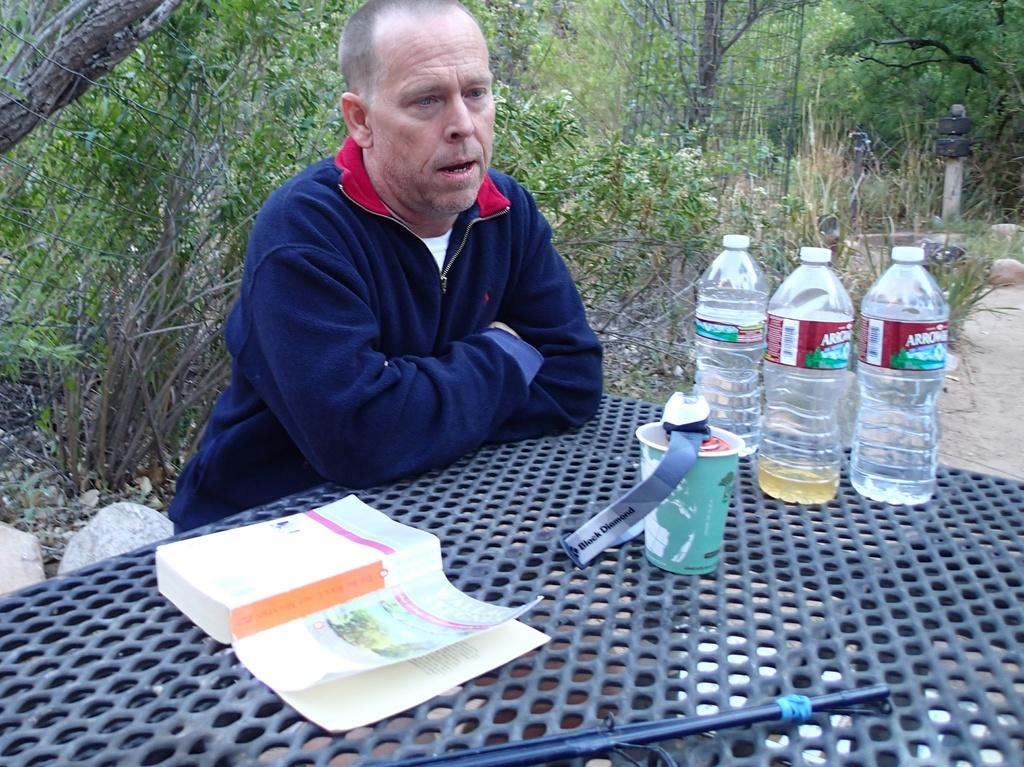What is the person in the image doing? There is a person sitting in the image. What object is on the table in the image? There is a book and a cup on the table in the image. How many water bottles are on the table in the image? There are three water bottles on the table in the image. What can be seen in the background of the image? There are trees in the background of the image. What type of chicken is the person holding in the image? There is no chicken present in the image; the person is sitting and not holding anything. 